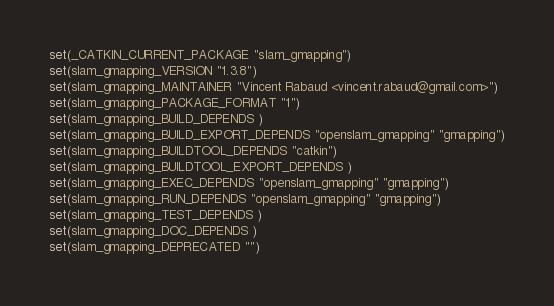Convert code to text. <code><loc_0><loc_0><loc_500><loc_500><_CMake_>set(_CATKIN_CURRENT_PACKAGE "slam_gmapping")
set(slam_gmapping_VERSION "1.3.8")
set(slam_gmapping_MAINTAINER "Vincent Rabaud <vincent.rabaud@gmail.com>")
set(slam_gmapping_PACKAGE_FORMAT "1")
set(slam_gmapping_BUILD_DEPENDS )
set(slam_gmapping_BUILD_EXPORT_DEPENDS "openslam_gmapping" "gmapping")
set(slam_gmapping_BUILDTOOL_DEPENDS "catkin")
set(slam_gmapping_BUILDTOOL_EXPORT_DEPENDS )
set(slam_gmapping_EXEC_DEPENDS "openslam_gmapping" "gmapping")
set(slam_gmapping_RUN_DEPENDS "openslam_gmapping" "gmapping")
set(slam_gmapping_TEST_DEPENDS )
set(slam_gmapping_DOC_DEPENDS )
set(slam_gmapping_DEPRECATED "")</code> 